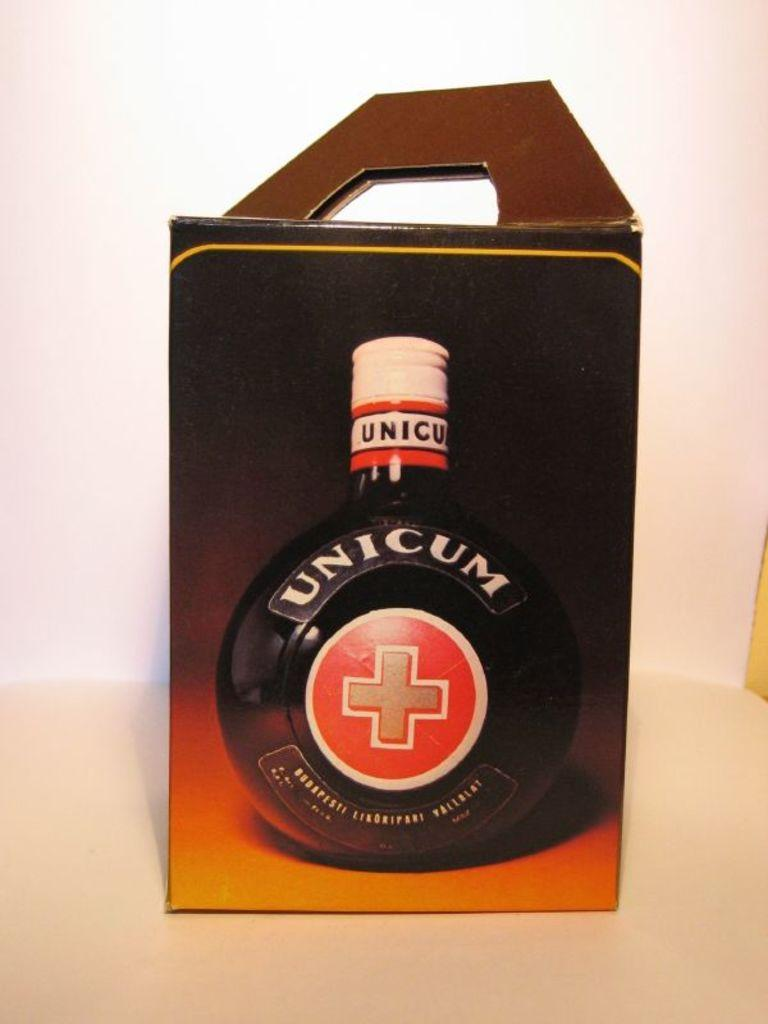<image>
Give a short and clear explanation of the subsequent image. A box of Unicom is seen against a pink and white background 